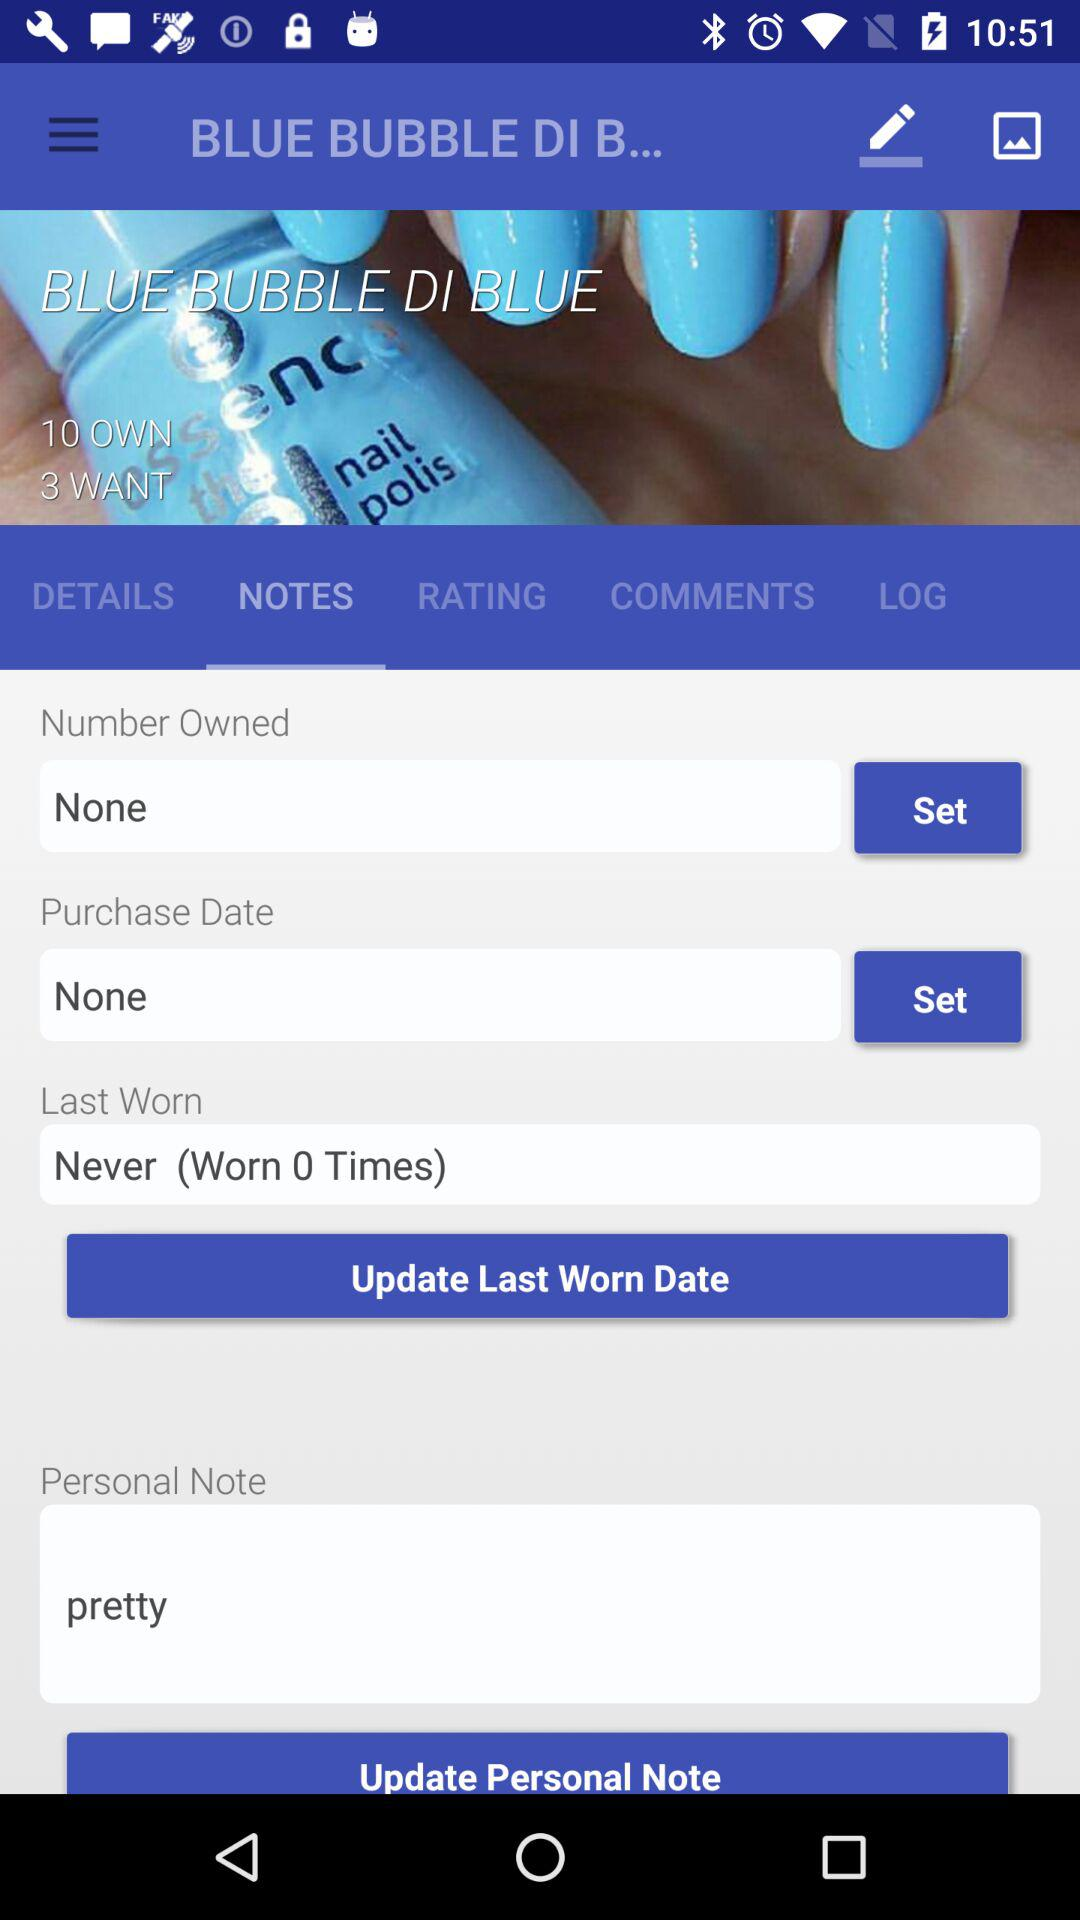What is written on a personal note? On a personal note, "pretty" is written. 